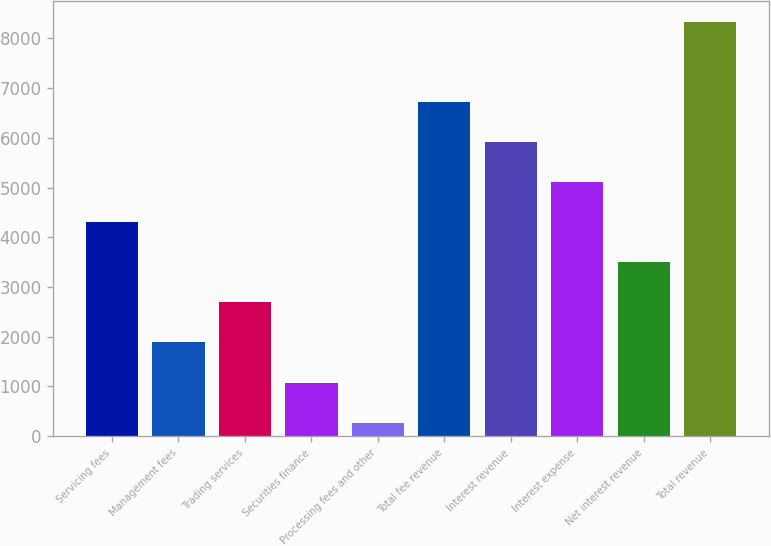Convert chart. <chart><loc_0><loc_0><loc_500><loc_500><bar_chart><fcel>Servicing fees<fcel>Management fees<fcel>Trading services<fcel>Securities finance<fcel>Processing fees and other<fcel>Total fee revenue<fcel>Interest revenue<fcel>Interest expense<fcel>Net interest revenue<fcel>Total revenue<nl><fcel>4303.5<fcel>1884<fcel>2690.5<fcel>1077.5<fcel>271<fcel>6723<fcel>5916.5<fcel>5110<fcel>3497<fcel>8336<nl></chart> 